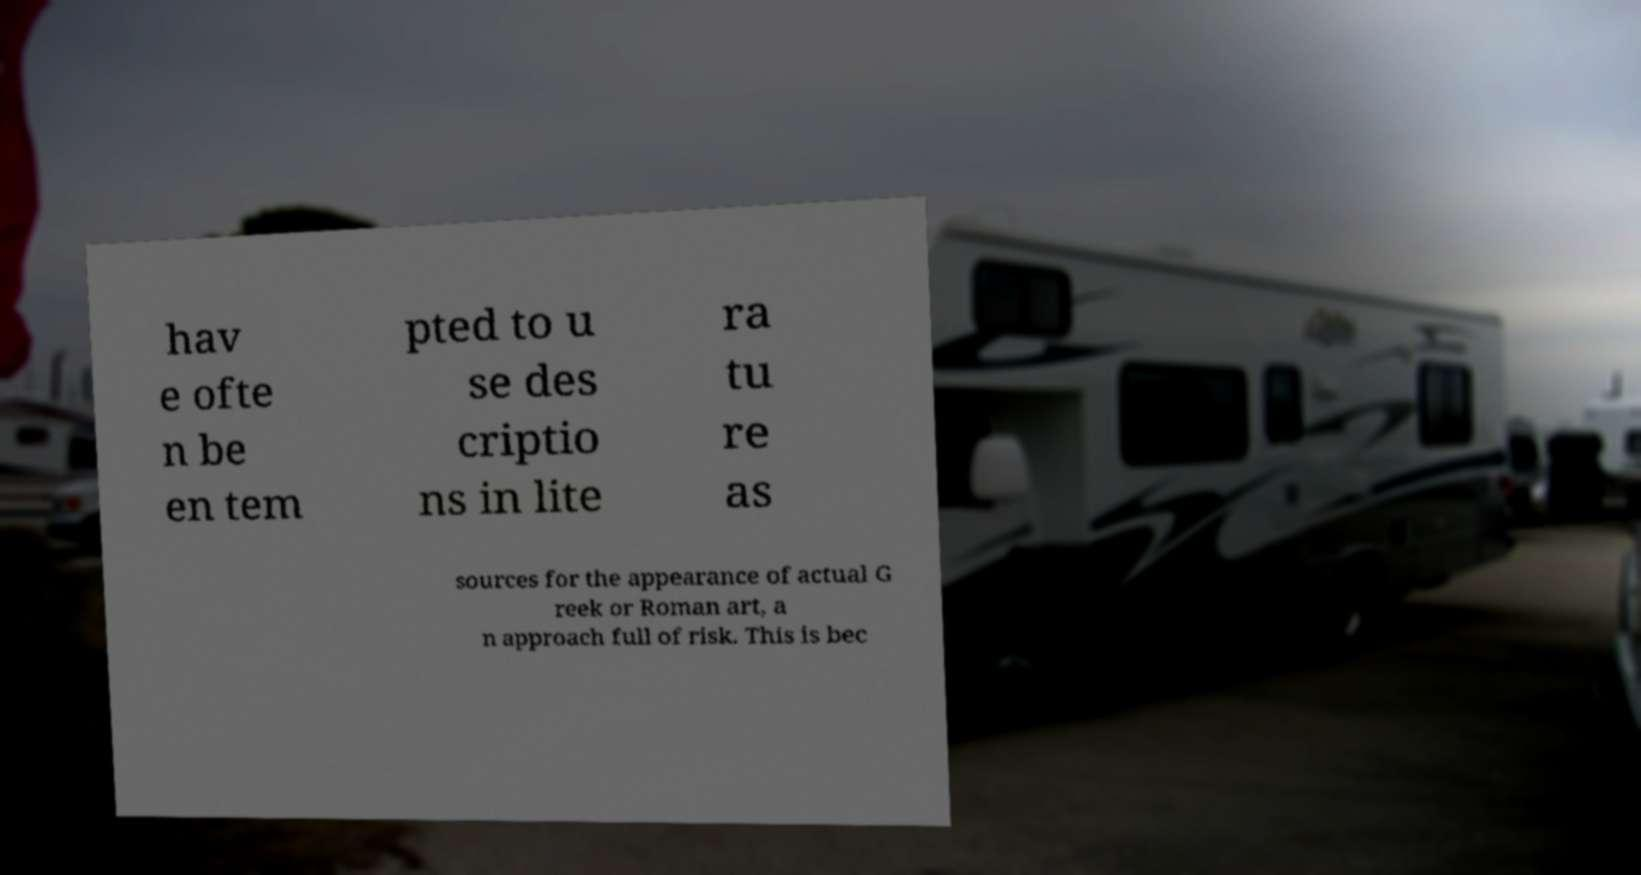What messages or text are displayed in this image? I need them in a readable, typed format. hav e ofte n be en tem pted to u se des criptio ns in lite ra tu re as sources for the appearance of actual G reek or Roman art, a n approach full of risk. This is bec 